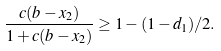<formula> <loc_0><loc_0><loc_500><loc_500>\frac { c ( b - x _ { 2 } ) } { 1 + c ( b - x _ { 2 } ) } \geq 1 - ( 1 - d _ { 1 } ) / 2 .</formula> 